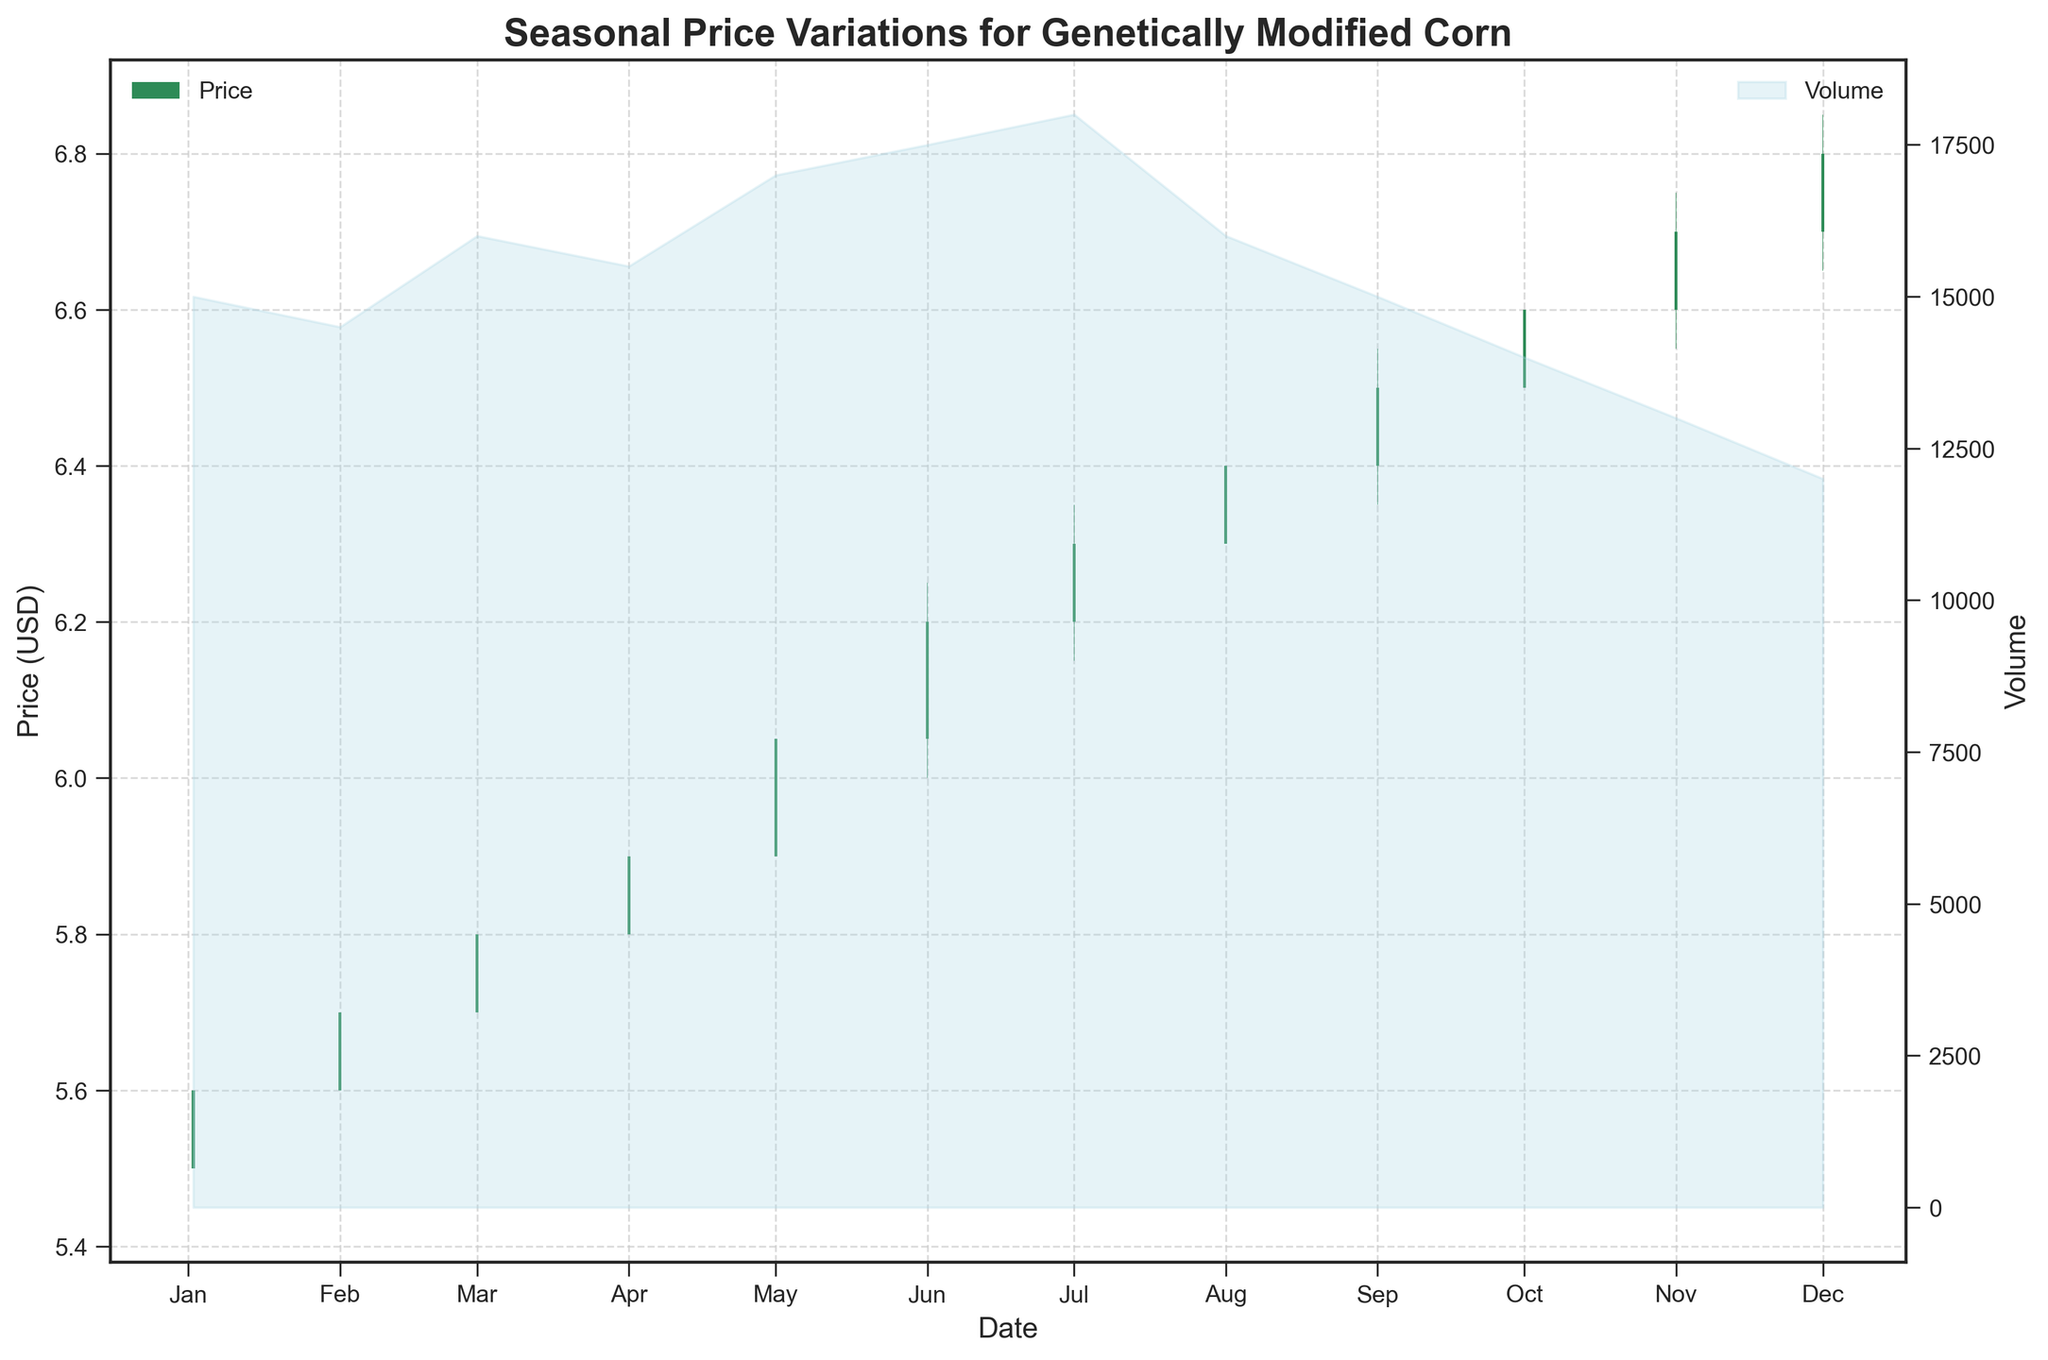What's the title of the plot? The plot's title is typically found at the top center of the figure. In this case, it reads "Seasonal Price Variations for Genetically Modified Corn".
Answer: Seasonal Price Variations for Genetically Modified Corn What is the highest price recorded in the year? Look for the highest value on the y-axis labeled 'Price (USD)'. This corresponds to the highest point on any of the candlesticks, which is in December with a high of 6.85 USD.
Answer: 6.85 USD In which month did the volume peak? Examine the secondary y-axis labeled 'Volume' and identify the peak of the filled area chart. The peak occurs in July.
Answer: July What is the overall trend in the price of genetically modified corn throughout the year? Observe the general direction of the candlesticks from January to December. The prices show a clear upward trend.
Answer: Upward Which color indicates a month where the closing price was higher than the opening price? Candlesticks where the closing price is higher than the opening price are colored seagreen.
Answer: Seagreen How does the trend in trading volume change across the year? View the filled area chart on the secondary y-axis to see how the volume fluctuates. It generally decreases after peaking in July.
Answer: Decreases after July In which months did the close price of genetically modified corn decrease compared to the open price? Identify the months where candlesticks are colored crimson, indicating a decrease in the close price compared to the open price. There are no crimson colored bars, hence no months had a decrease.
Answer: None What is the price range (difference between highest and lowest prices) for April? Find the high and low price values for April. April's high is 5.95 USD and the low is 5.75 USD. The difference is 0.20 USD.
Answer: 0.20 USD Compare the closing prices between June and December. Identify the close prices for June and December, which are 6.20 USD and 6.80 USD respectively. December's closing price is higher than June's.
Answer: December's closing price is higher How many months have a trading volume less than 15,000? Compare the volume for each month against 15,000 and count the months below this threshold. There are six months with a volume less than 15,000: January, February, October, November, and December.
Answer: 6 months 